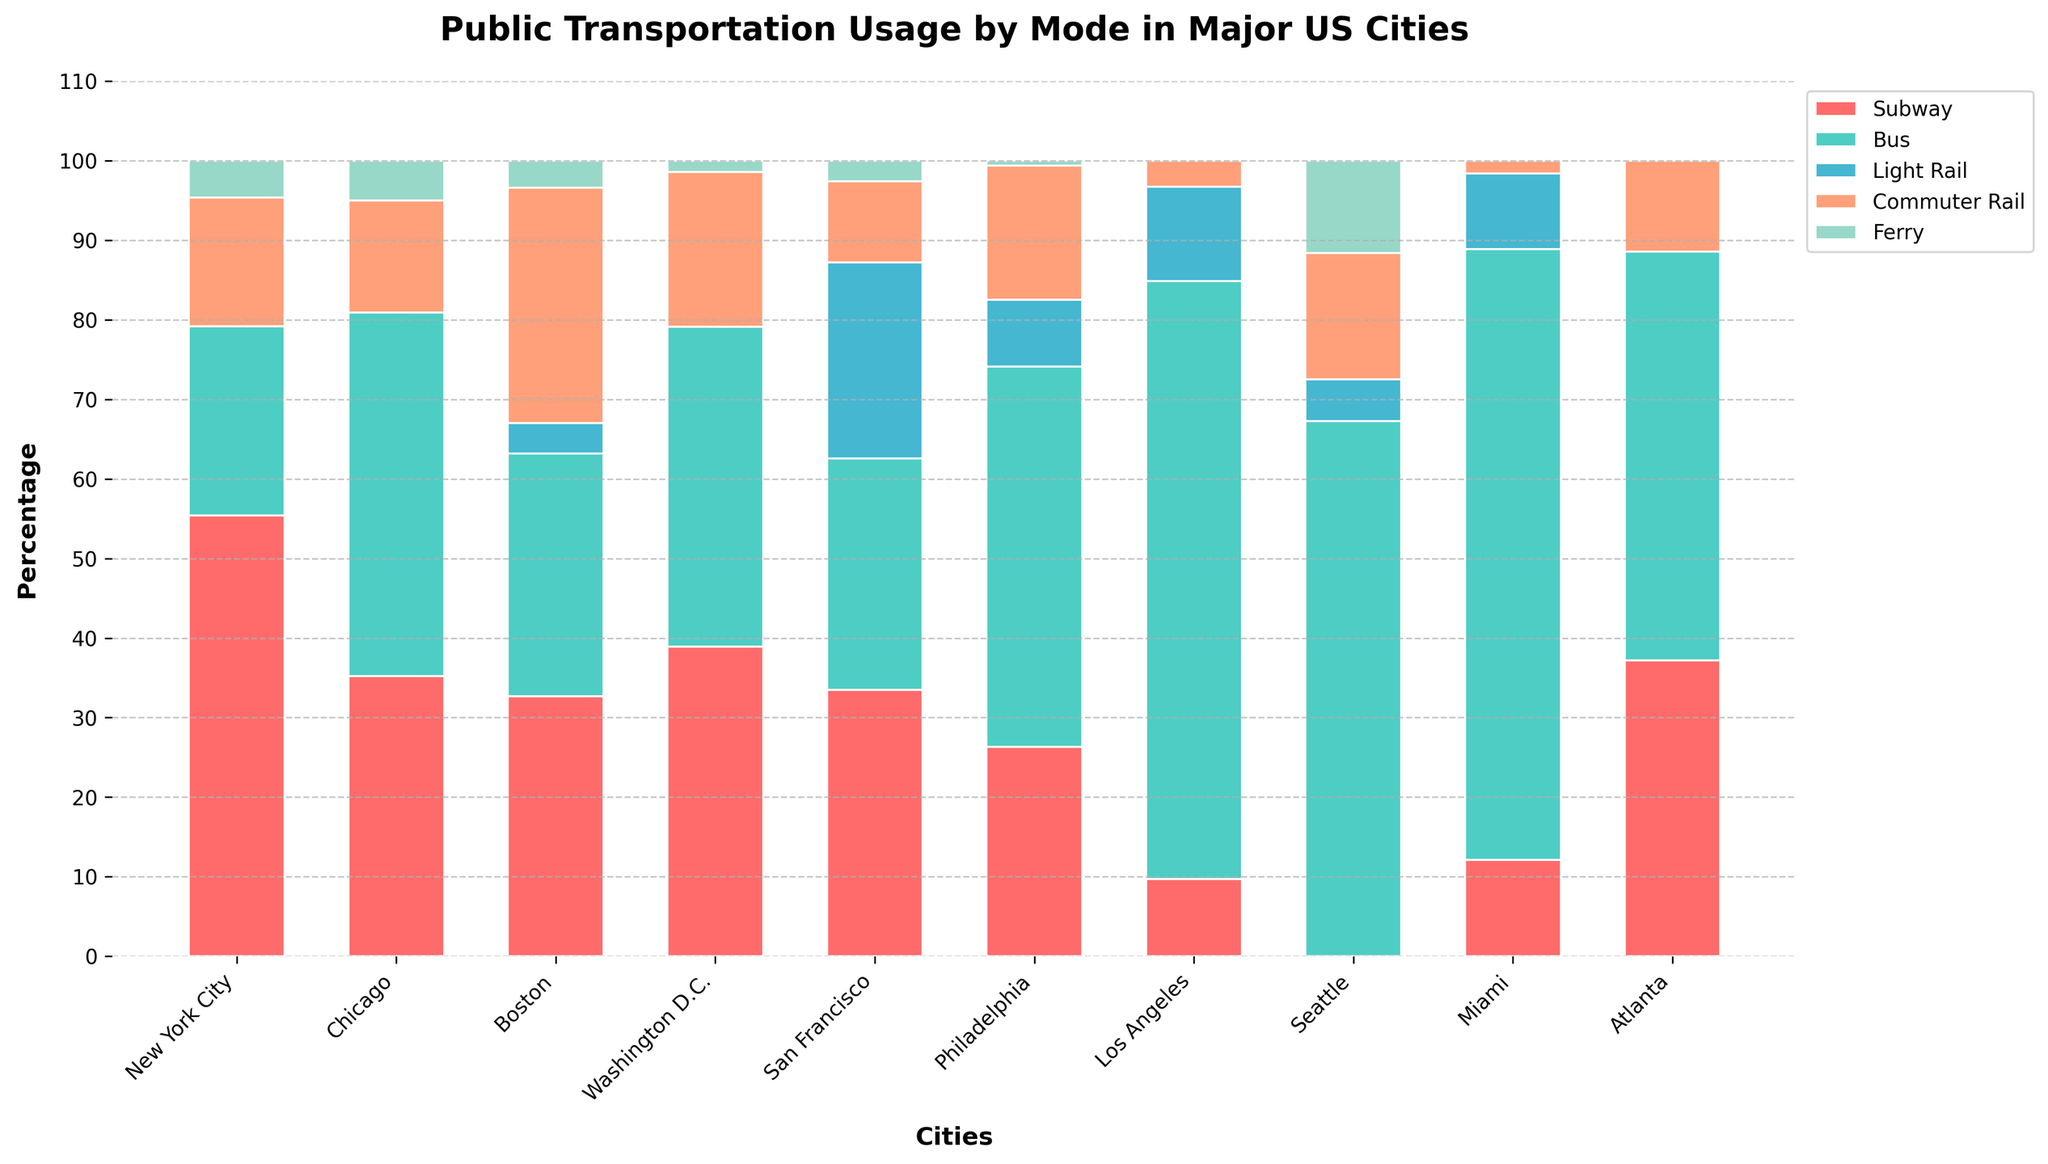How does the percentage of bus usage in Washington D.C. compare to bus usage in Philadelphia? The percentage of bus usage in Washington D.C. is 40.2%, while in Philadelphia it is 47.8%. Comparing these values, bus usage in Washington D.C. is less than in Philadelphia.
Answer: Less Which city has the highest percentage of subway usage? By examining the heights of the red bars representing subway usage across the cities, New York City has the highest percentage at 55.4%.
Answer: New York City What is the combined percentage of light rail and ferry usage in San Francisco? In San Francisco, the light rail usage is 24.6% and ferry usage is 2.6%. Adding these two values gives 24.6 + 2.6 = 27.2%.
Answer: 27.2% Which city uses buses the most, and by what percentage? The city with the highest bus usage is determined by the tallest green bar for buses. Miami has the highest bus usage at 76.8%.
Answer: Miami, 76.8% Compare the total percentage of transportation usage modes (excluding 'Other' categories) in New York City and Boston. Which city has a higher total percentage? Sum the percentages for subway, bus, light rail, commuter rail, and ferry in both cities. New York City's total is 55.4 + 23.8 + 0 + 16.2 + 4.6 = 100%, while Boston's total is 32.7 + 30.5 + 3.8 + 29.6 + 3.4 = 100%. Both cities have the same total usage of 100%.
Answer: Equal (100%) How much greater is the subway usage in New York City compared to Chicago? The percentage of subway usage in New York City is 55.4%, and in Chicago, it is 35.2%. Subtracting these values gives 55.4 - 35.2 = 20.2%.
Answer: 20.2% What is the average percentage of commuter rail usage across all cities? Add all the commuter rail percentages and divide by the number of cities: (16.2 + 14.1 + 29.6 + 19.5 + 10.2 + 16.9 + 3.3 + 15.9 + 1.6 + 11.4) / 10. The sum is 138.7, and dividing by 10 gives 13.87%.
Answer: 13.87% Which transportation mode is used least in Miami? By examining the heights of the bars for each mode in Miami, the light rail (9.5%) and ferry (0%) have the lowest heights, with ferry usage being zero.
Answer: Ferry Which two cities have the closest percentage of bus usage? By comparing the percentages closely, Washington D.C. (40.2%) and San Francisco (29.1%) have the closest bus usage values.
Answer: Washington D.C. and San Francisco 